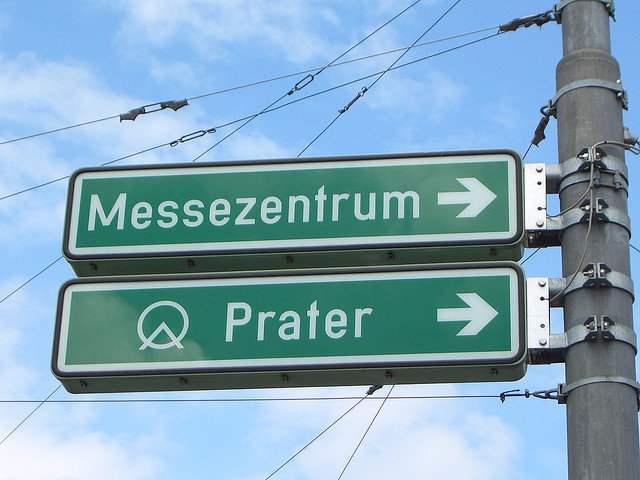Describe the objects in this image and their specific colors. I can see various objects in this image with different colors. 